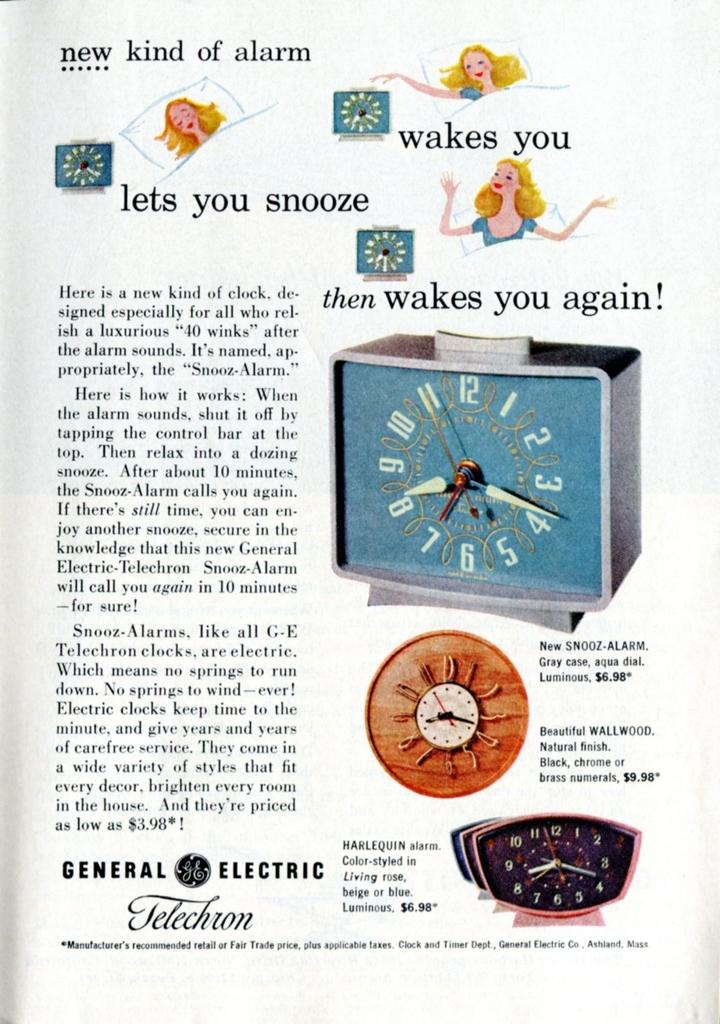Provide a one-sentence caption for the provided image. A picture of an advertisements that says New Kind of Alarm. 